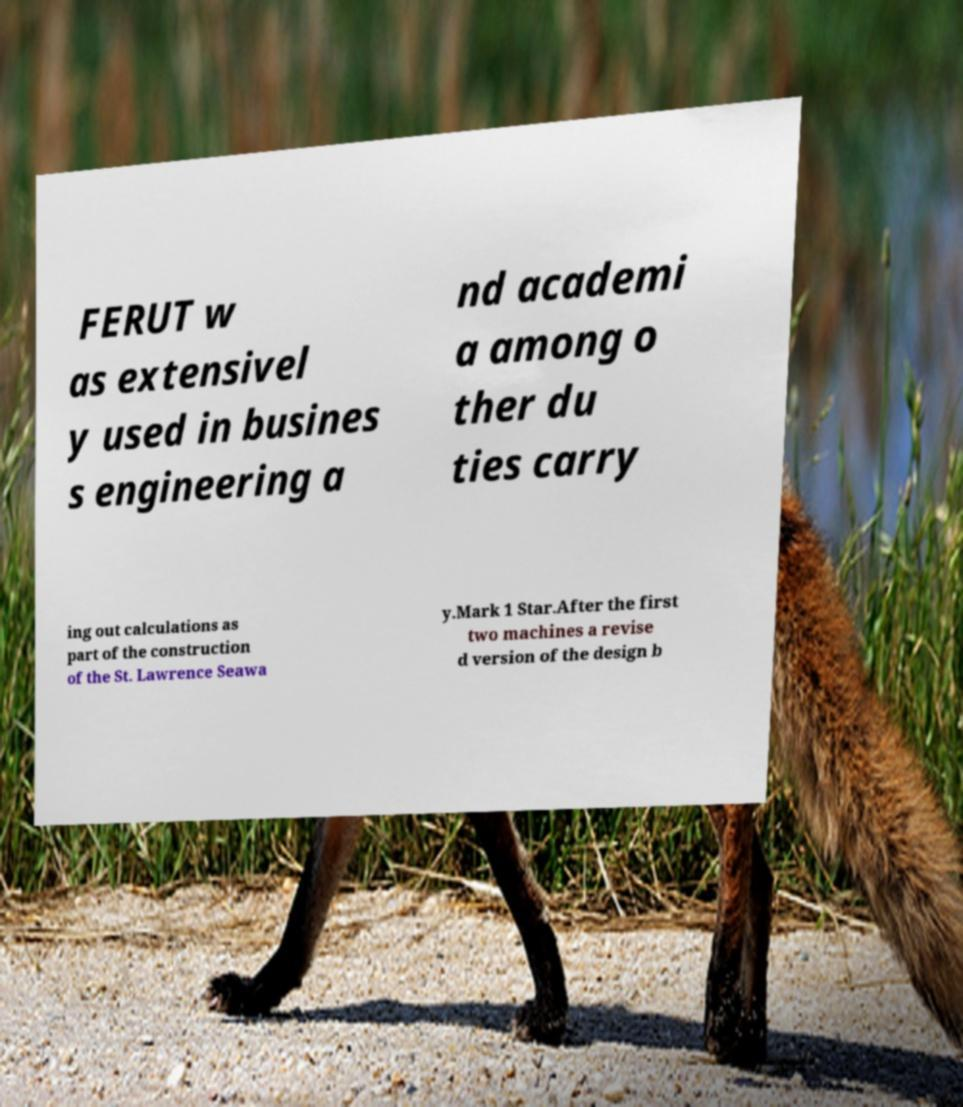Please read and relay the text visible in this image. What does it say? FERUT w as extensivel y used in busines s engineering a nd academi a among o ther du ties carry ing out calculations as part of the construction of the St. Lawrence Seawa y.Mark 1 Star.After the first two machines a revise d version of the design b 